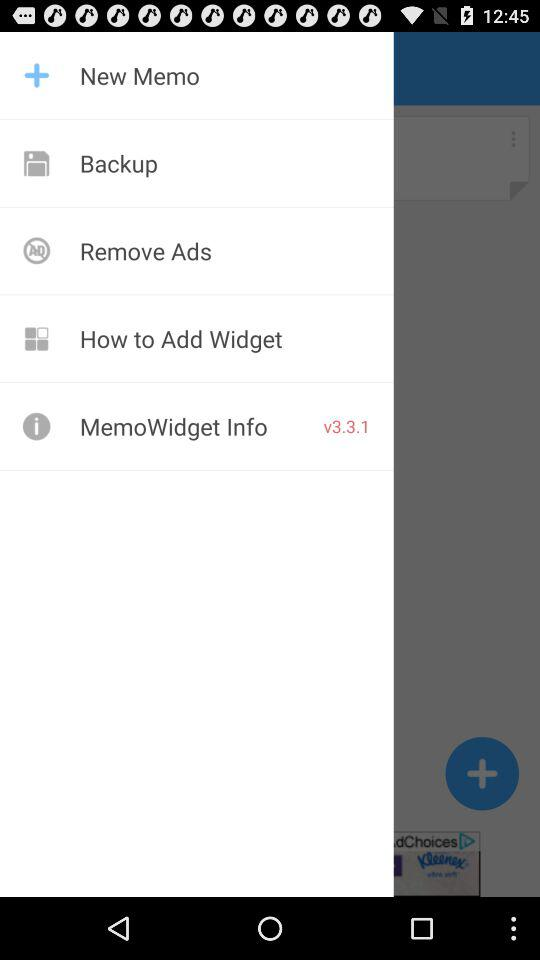What is the version? The version is 3.3.1. 